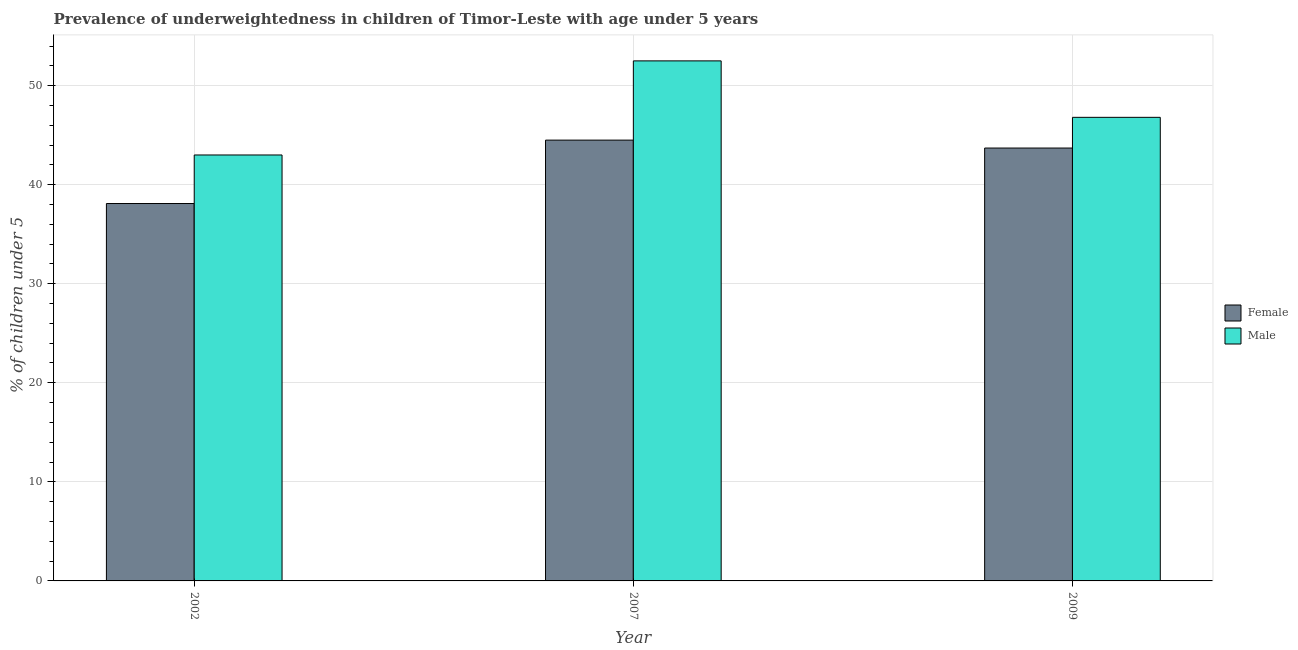How many different coloured bars are there?
Your answer should be very brief. 2. How many groups of bars are there?
Give a very brief answer. 3. Are the number of bars per tick equal to the number of legend labels?
Offer a terse response. Yes. Are the number of bars on each tick of the X-axis equal?
Your answer should be compact. Yes. How many bars are there on the 2nd tick from the right?
Provide a short and direct response. 2. In how many cases, is the number of bars for a given year not equal to the number of legend labels?
Offer a very short reply. 0. What is the percentage of underweighted female children in 2002?
Provide a short and direct response. 38.1. Across all years, what is the maximum percentage of underweighted male children?
Make the answer very short. 52.5. Across all years, what is the minimum percentage of underweighted female children?
Ensure brevity in your answer.  38.1. What is the total percentage of underweighted female children in the graph?
Your answer should be very brief. 126.3. What is the difference between the percentage of underweighted male children in 2002 and that in 2009?
Your answer should be very brief. -3.8. What is the difference between the percentage of underweighted female children in 2002 and the percentage of underweighted male children in 2007?
Provide a short and direct response. -6.4. What is the average percentage of underweighted female children per year?
Your response must be concise. 42.1. What is the ratio of the percentage of underweighted male children in 2002 to that in 2009?
Keep it short and to the point. 0.92. Is the difference between the percentage of underweighted female children in 2002 and 2007 greater than the difference between the percentage of underweighted male children in 2002 and 2007?
Your answer should be very brief. No. What is the difference between the highest and the second highest percentage of underweighted male children?
Your response must be concise. 5.7. In how many years, is the percentage of underweighted female children greater than the average percentage of underweighted female children taken over all years?
Your response must be concise. 2. What does the 1st bar from the left in 2002 represents?
Keep it short and to the point. Female. Does the graph contain any zero values?
Offer a very short reply. No. Does the graph contain grids?
Your answer should be compact. Yes. How are the legend labels stacked?
Your answer should be compact. Vertical. What is the title of the graph?
Offer a very short reply. Prevalence of underweightedness in children of Timor-Leste with age under 5 years. Does "Secondary school" appear as one of the legend labels in the graph?
Give a very brief answer. No. What is the label or title of the Y-axis?
Your answer should be very brief.  % of children under 5. What is the  % of children under 5 in Female in 2002?
Provide a short and direct response. 38.1. What is the  % of children under 5 of Female in 2007?
Your response must be concise. 44.5. What is the  % of children under 5 in Male in 2007?
Your answer should be compact. 52.5. What is the  % of children under 5 in Female in 2009?
Your response must be concise. 43.7. What is the  % of children under 5 in Male in 2009?
Keep it short and to the point. 46.8. Across all years, what is the maximum  % of children under 5 in Female?
Offer a very short reply. 44.5. Across all years, what is the maximum  % of children under 5 of Male?
Ensure brevity in your answer.  52.5. Across all years, what is the minimum  % of children under 5 in Female?
Offer a terse response. 38.1. What is the total  % of children under 5 in Female in the graph?
Your answer should be compact. 126.3. What is the total  % of children under 5 of Male in the graph?
Ensure brevity in your answer.  142.3. What is the difference between the  % of children under 5 of Female in 2002 and that in 2007?
Make the answer very short. -6.4. What is the difference between the  % of children under 5 of Female in 2002 and that in 2009?
Your answer should be very brief. -5.6. What is the difference between the  % of children under 5 in Male in 2002 and that in 2009?
Provide a succinct answer. -3.8. What is the difference between the  % of children under 5 in Female in 2002 and the  % of children under 5 in Male in 2007?
Offer a terse response. -14.4. What is the difference between the  % of children under 5 in Female in 2002 and the  % of children under 5 in Male in 2009?
Keep it short and to the point. -8.7. What is the difference between the  % of children under 5 in Female in 2007 and the  % of children under 5 in Male in 2009?
Your response must be concise. -2.3. What is the average  % of children under 5 of Female per year?
Ensure brevity in your answer.  42.1. What is the average  % of children under 5 of Male per year?
Your response must be concise. 47.43. In the year 2002, what is the difference between the  % of children under 5 in Female and  % of children under 5 in Male?
Your answer should be compact. -4.9. What is the ratio of the  % of children under 5 in Female in 2002 to that in 2007?
Make the answer very short. 0.86. What is the ratio of the  % of children under 5 of Male in 2002 to that in 2007?
Keep it short and to the point. 0.82. What is the ratio of the  % of children under 5 in Female in 2002 to that in 2009?
Offer a very short reply. 0.87. What is the ratio of the  % of children under 5 of Male in 2002 to that in 2009?
Your answer should be compact. 0.92. What is the ratio of the  % of children under 5 in Female in 2007 to that in 2009?
Provide a short and direct response. 1.02. What is the ratio of the  % of children under 5 in Male in 2007 to that in 2009?
Ensure brevity in your answer.  1.12. 